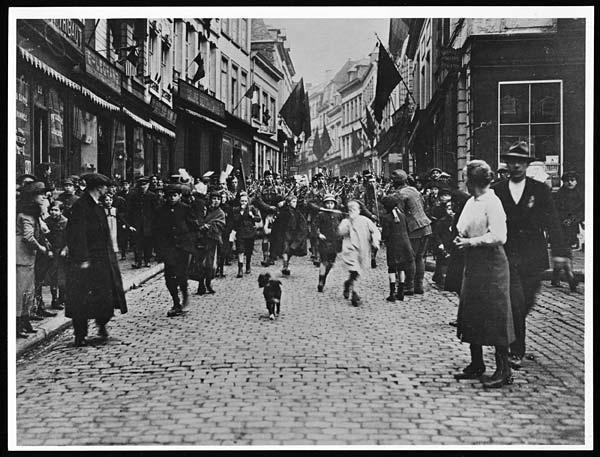What number of people are walking on the street?
Be succinct. 7. How many flags are there?
Be succinct. 5. How many females in the group?
Answer briefly. 2. What flag is in the background?
Be succinct. Unknown. How many females are there?
Quick response, please. Lot. Where are the people?
Give a very brief answer. Street. Why are the people in the middle running?
Keep it brief. Parade. Do these people seem to know each other?
Concise answer only. No. Are there any girls in this picture?
Quick response, please. Yes. 